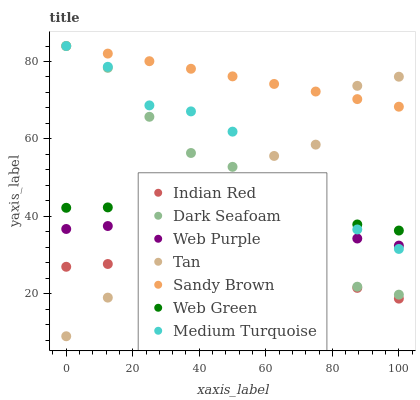Does Indian Red have the minimum area under the curve?
Answer yes or no. Yes. Does Sandy Brown have the maximum area under the curve?
Answer yes or no. Yes. Does Web Purple have the minimum area under the curve?
Answer yes or no. No. Does Web Purple have the maximum area under the curve?
Answer yes or no. No. Is Sandy Brown the smoothest?
Answer yes or no. Yes. Is Tan the roughest?
Answer yes or no. Yes. Is Web Purple the smoothest?
Answer yes or no. No. Is Web Purple the roughest?
Answer yes or no. No. Does Tan have the lowest value?
Answer yes or no. Yes. Does Web Purple have the lowest value?
Answer yes or no. No. Does Sandy Brown have the highest value?
Answer yes or no. Yes. Does Web Purple have the highest value?
Answer yes or no. No. Is Web Purple less than Web Green?
Answer yes or no. Yes. Is Sandy Brown greater than Web Purple?
Answer yes or no. Yes. Does Dark Seafoam intersect Medium Turquoise?
Answer yes or no. Yes. Is Dark Seafoam less than Medium Turquoise?
Answer yes or no. No. Is Dark Seafoam greater than Medium Turquoise?
Answer yes or no. No. Does Web Purple intersect Web Green?
Answer yes or no. No. 